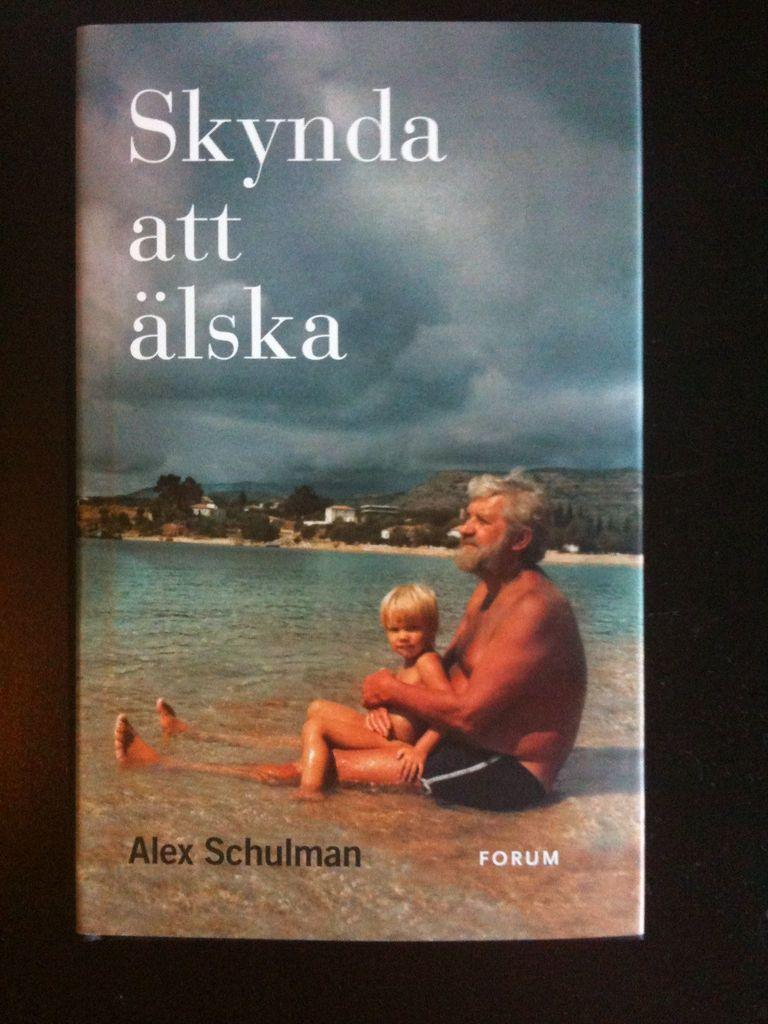<image>
Provide a brief description of the given image. A book by Alex Schulman has a father and son on the cover. 